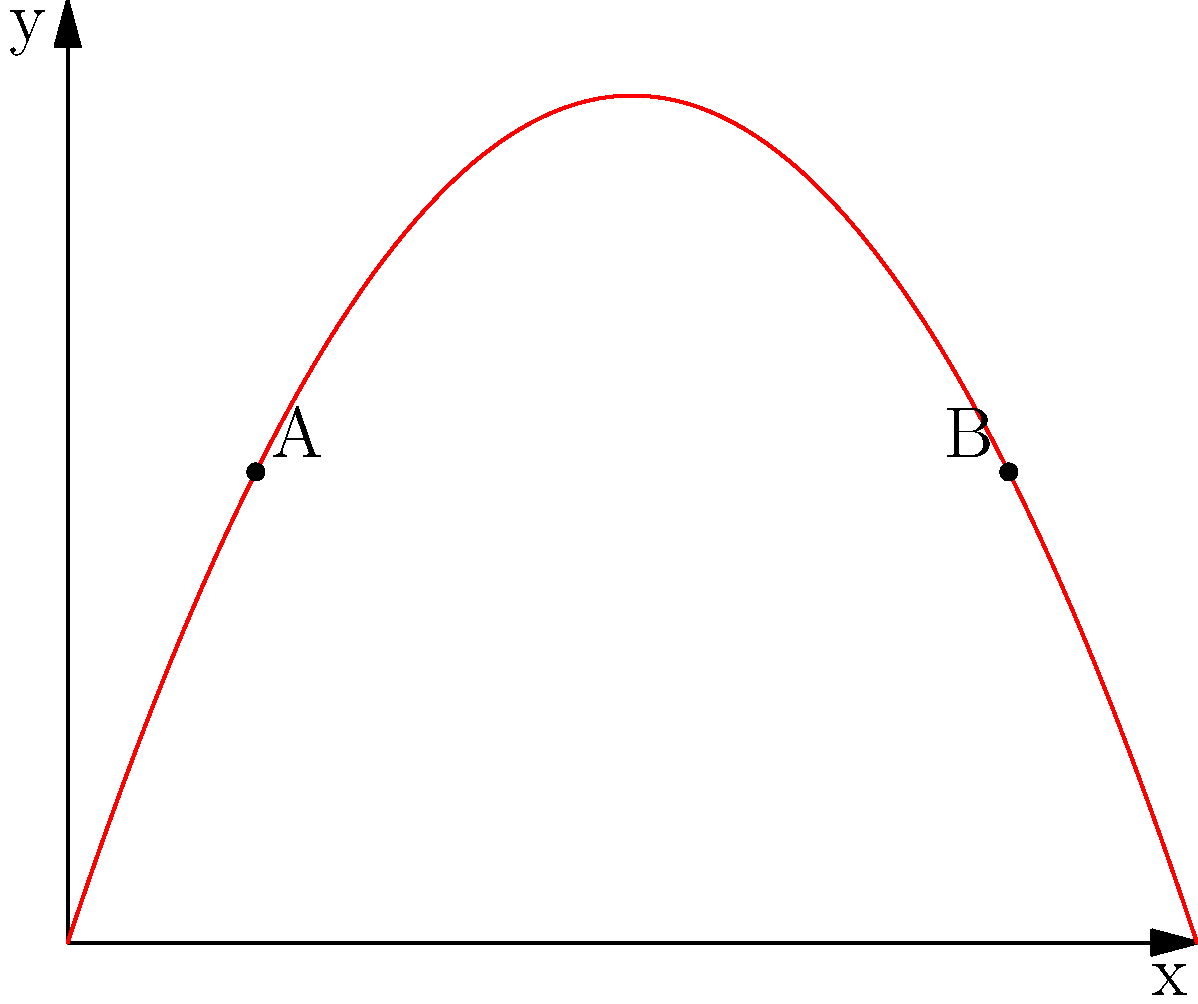In a crucial tennis match, you hit a perfect lob shot. The trajectory of the tennis ball can be modeled by the function $f(x)=-0.5x^2+3x$, where $x$ represents the horizontal distance and $f(x)$ represents the height of the ball, both measured in meters. Calculate the slope of the line connecting points A(1, 2.5) and B(5, 2.5) on the ball's path. How does this slope relate to the ball's motion at these points? To solve this problem, let's follow these steps:

1) The slope formula between two points $(x_1,y_1)$ and $(x_2,y_2)$ is:

   $m = \frac{y_2 - y_1}{x_2 - x_1}$

2) For points A(1, 2.5) and B(5, 2.5):
   $(x_1,y_1) = (1, 2.5)$ and $(x_2,y_2) = (5, 2.5)$

3) Plugging these into the slope formula:

   $m = \frac{2.5 - 2.5}{5 - 1} = \frac{0}{4} = 0$

4) The slope of the line connecting A and B is 0, which means it's a horizontal line.

5) In terms of the ball's motion:
   - At point A, the ball is still rising (positive slope of the curve).
   - At point B, the ball is falling (negative slope of the curve).
   - The horizontal line connecting these points represents the maximum height of the ball's trajectory.

6) The slope being 0 indicates that the rate of change in height between these two points is zero, confirming that this line touches the highest point of the ball's path.
Answer: 0; represents maximum height of trajectory 